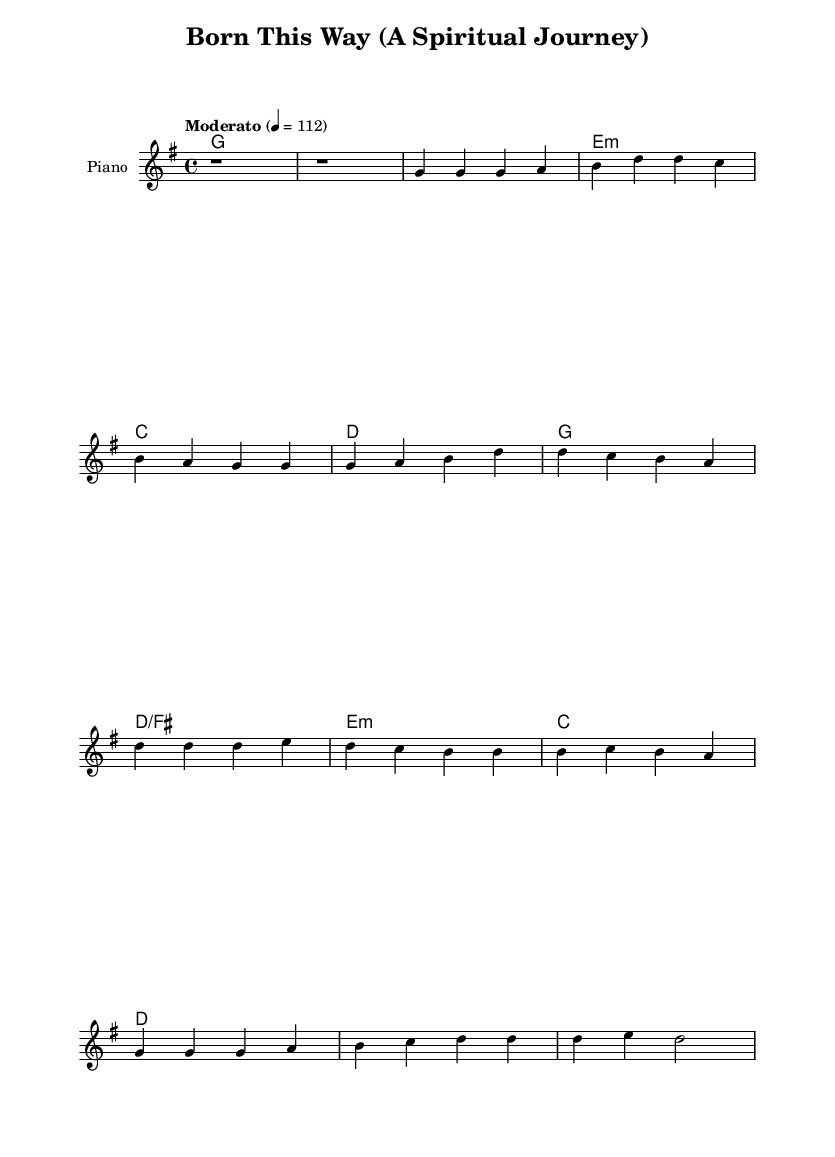What is the key signature of this music? The key signature is G major, indicated by one sharp on the F line in the staff.
Answer: G major What is the time signature of this music? The time signature is 4/4, which is commonly represented by four beats in a measure with a quarter note getting one beat.
Answer: 4/4 What is the tempo marking for this piece? The tempo marking is "Moderato," which denotes a moderate pace, and it is indicated above the staff as 4 equals 112 BPM.
Answer: Moderato How many measures are in the intro section? The intro section consists of two measures, which is evident from the rest notation at the beginning of the score.
Answer: 2 Which chord is played with the first measure of the verse? The chord played in the first measure of the verse is G major, indicated by the chord name above the staff.
Answer: G What is the last note of the chorus melody? The last note of the chorus melody is D, which can be found in the melodic line at the end of that section.
Answer: D What is the quality of the second chord in the verse? The second chord is E minor, which is typically represented by a lowercase 'm' next to the chord name, indicating its minor quality.
Answer: E minor 